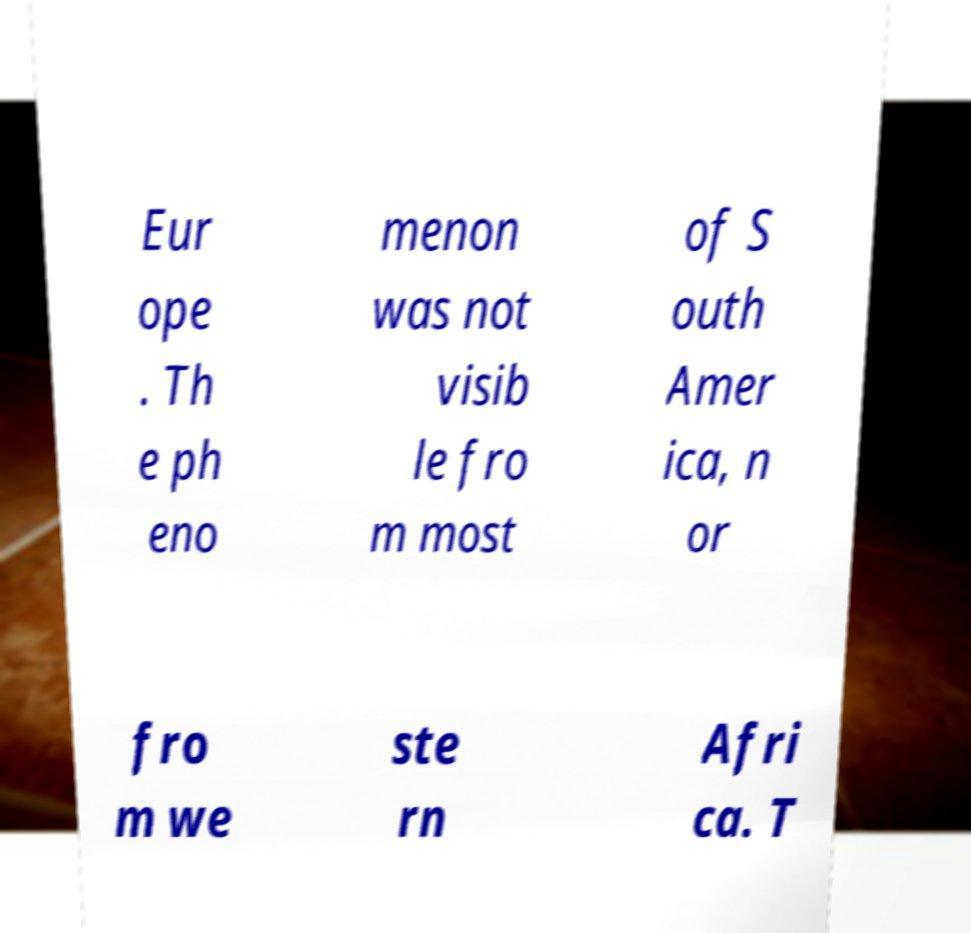Can you accurately transcribe the text from the provided image for me? Eur ope . Th e ph eno menon was not visib le fro m most of S outh Amer ica, n or fro m we ste rn Afri ca. T 